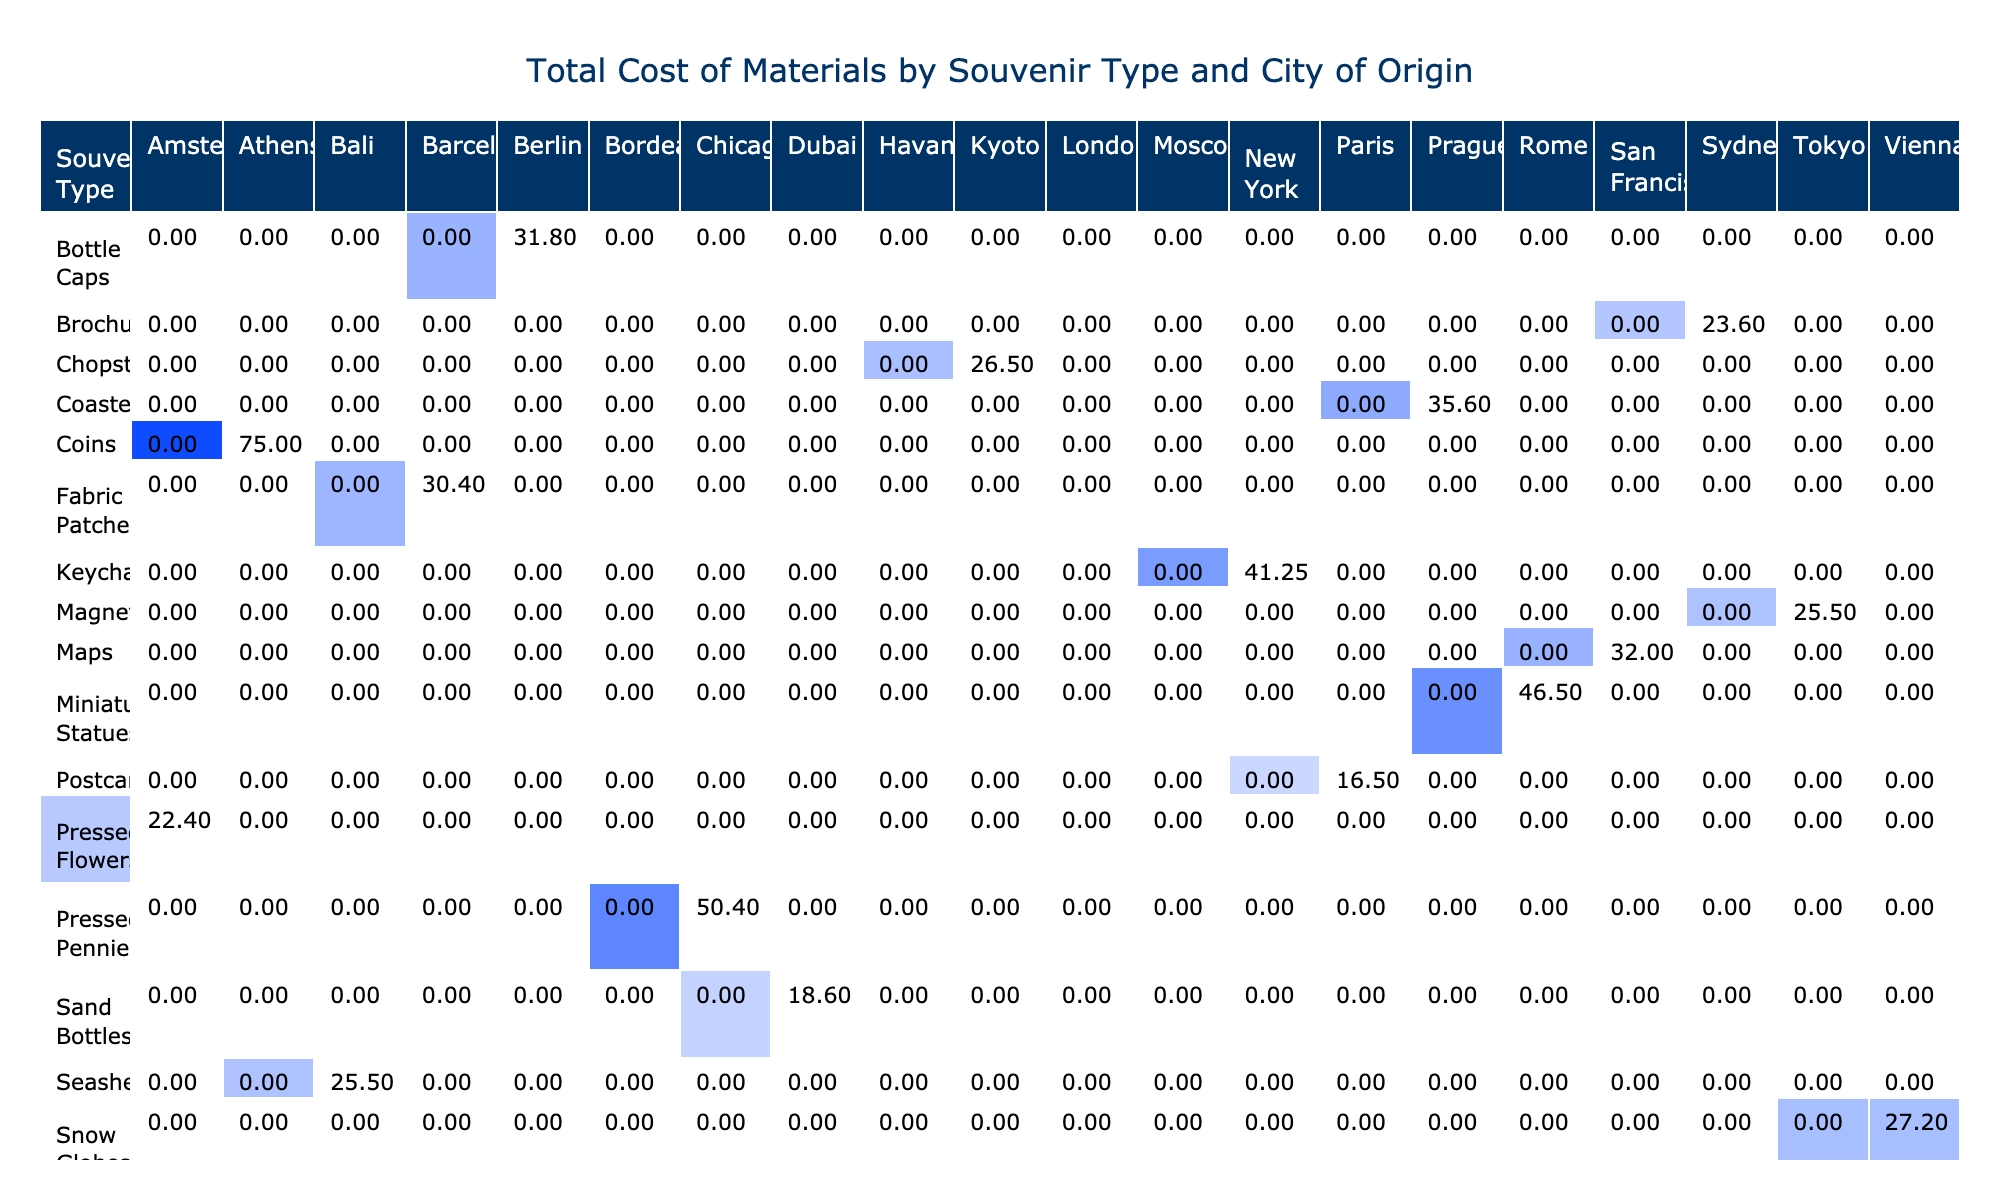What is the total cost of materials for artwork inspired by postcards? To find the total cost for postcards, I look at the column for postcards in the pivot table. The total cost is given directly in the table under the column for each city of origin. The values are 0 for all cities except for Paris, where it is 49.50.
Answer: 49.50 Which souvenir type has the highest total cost in the city of Athens? To determine the highest total cost in Athens, I examine the Athens column in the pivot table. I see that the only souvenir type listed is coins, which has a total cost of 75.00. Since it's the only type listed for Athens, it's also the highest.
Answer: 75.00 How many total cost contributions come from souvenirs originating in Rome? Looking at the pivot table, Rome has one type of souvenir, miniature statues, which has a total cost of 46.50. Since there is only one entry for Rome, it means the total is directly represented in that row.
Answer: 46.50 Is the total cost for seashells greater than the total cost for fabric patches? Checking the table, the total cost for seashells from Bali is 25.50, while for fabric patches from Barcelona, the total cost is 30.40. Thus, I compare the two numbers and see that 25.50 is less than 30.40. Therefore, the statement is false.
Answer: No What is the average total cost of materials for artwork inspired by souvenirs originating from London? First, I look for the souvenirs from London in the pivot table, which includes ticket stubs with a total cost of 7.50. Since there is only one entry, the average is equal to that single value of 7.50.
Answer: 7.50 Which city of origin contributes the highest total material cost overall? I must look at the total costs for all cities displayed in the pivot table. By examining each column, I find that Paris has the highest total, with 49.50 derived from postcards. Therefore, I can conclude that Paris is the city with the highest contribution.
Answer: Paris What is the combined total cost of materials for the souvenirs from Berlin and Moscow? From the pivot table, I identify that Berlin has a total cost of 31.80 from bottle caps and Moscow has a total cost of 29.00 from train tickets. I sum these two amounts: 31.80 + 29.00 = 60.80.
Answer: 60.80 How many total costs listed exceed 50.00? I analyze each total cost in the pivot table, counting how many are greater than 50.00. The entries with total costs over 50.00 are coins (75.00), and miniature statues (46.50). Only coins meet the criterion, giving a total of one entry that exceeds 50.00.
Answer: 1 